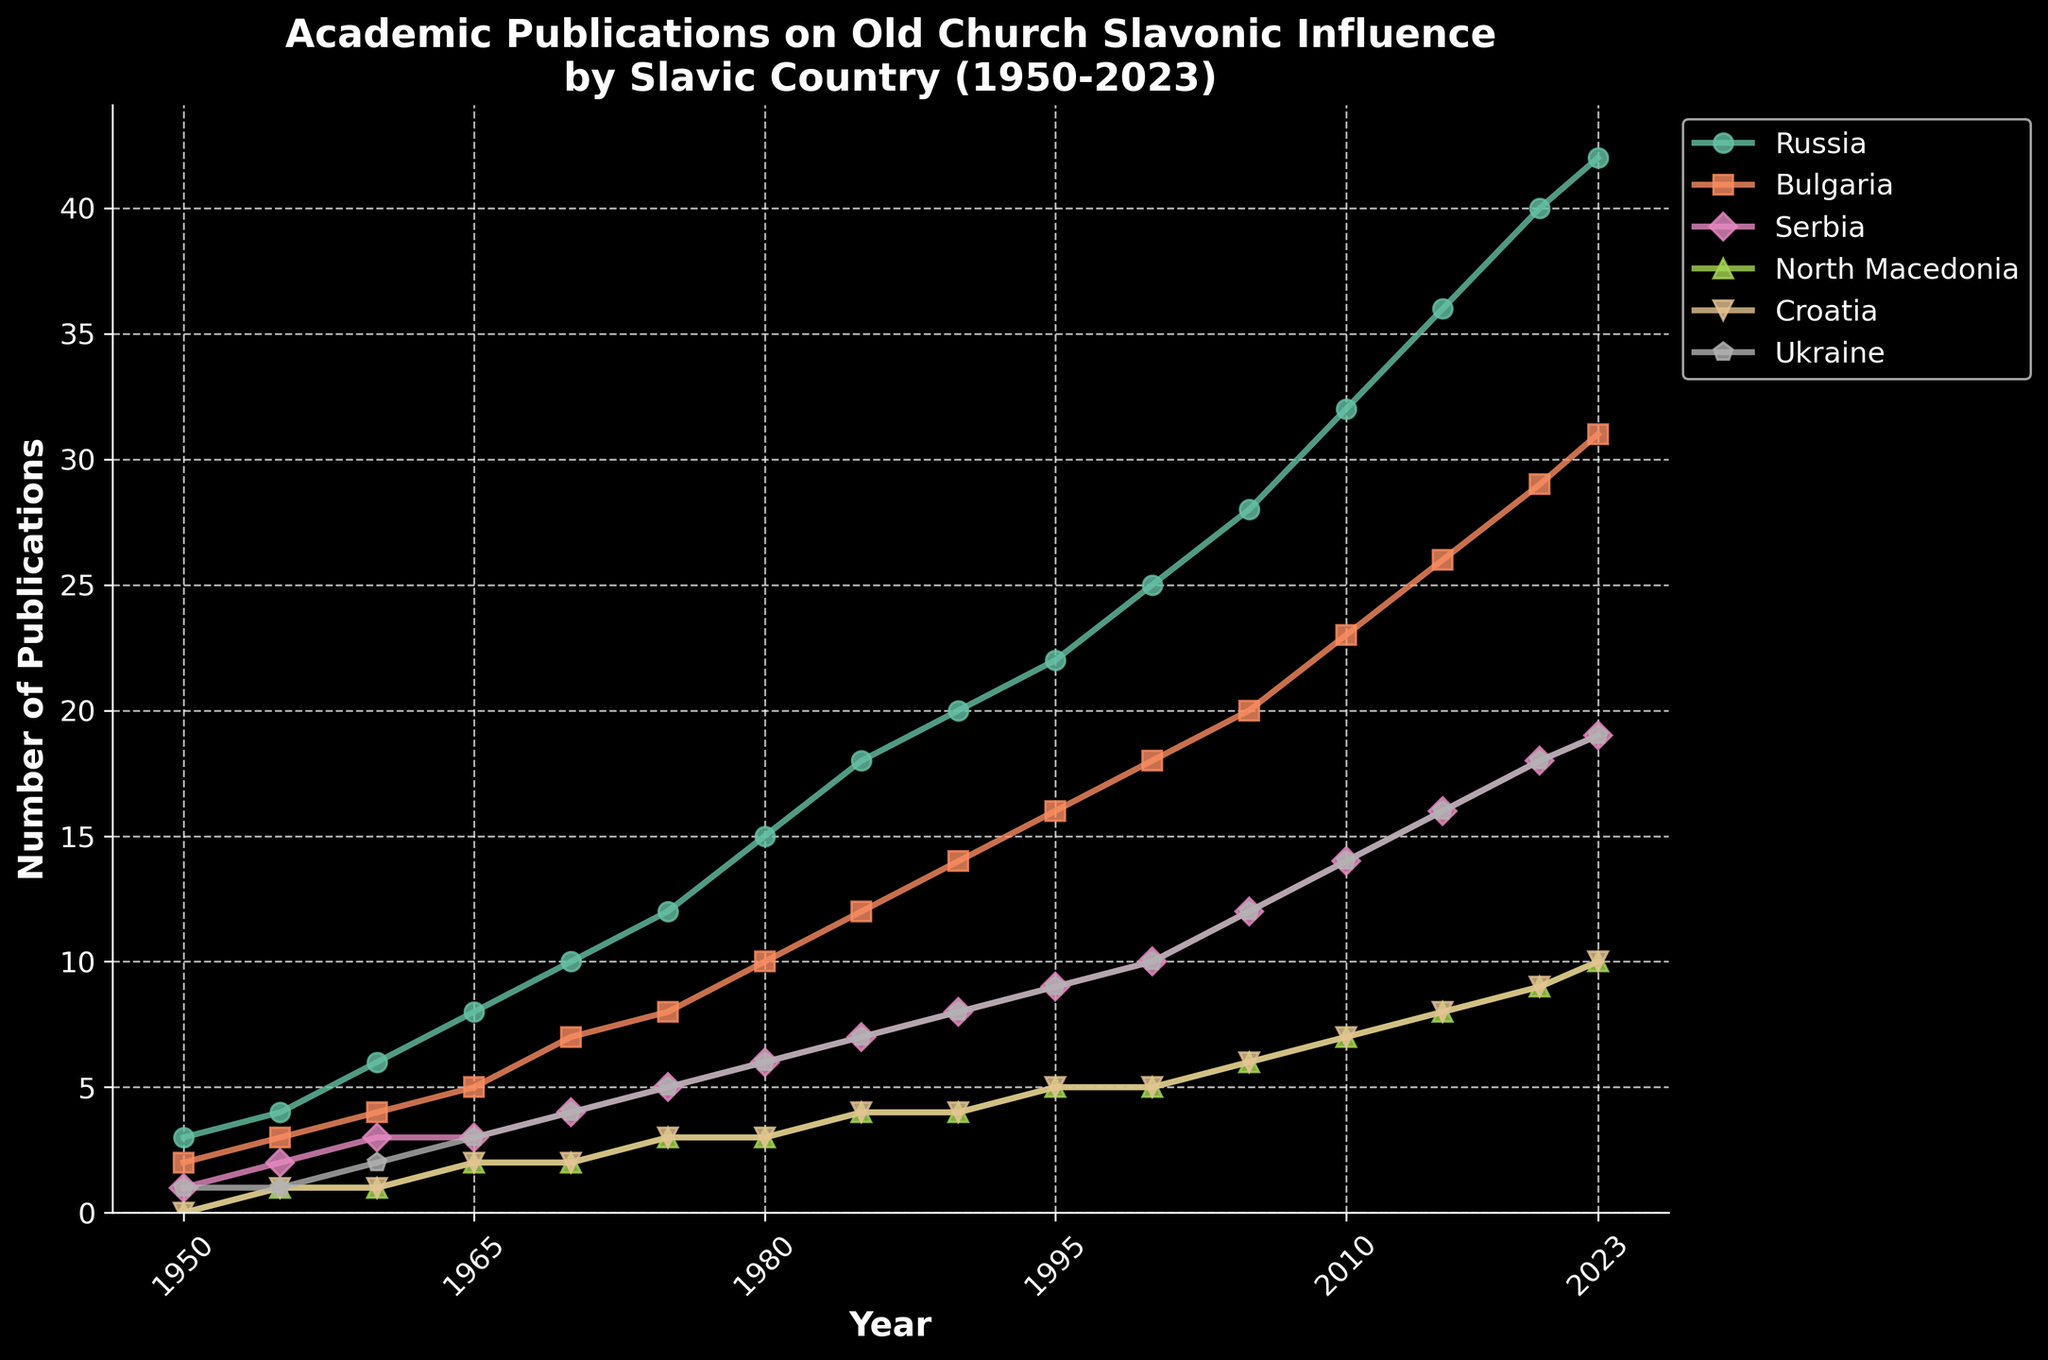Which country had the highest number of publications in the year 2023? To determine which country had the highest number of publications in 2023, look at the endpoints of the lines representing each country on the rightmost side of the figure. The line with the highest position on the y-axis indicates the country with the most publications. Russia's line is at the highest position.
Answer: Russia How many more publications did Russia have compared to North Macedonia in 1980? To find out how many more publications Russia had compared to North Macedonia in 1980, locate the corresponding points for both countries in the year 1980 on the x-axis. Note the y-values: Russia had 15 publications and North Macedonia had 3 publications. The difference is 15 - 3.
Answer: 12 Which country shows the most consistent increase in publications from 1950 to 2023? To determine the country with the most consistent increase, look at the slope and smoothness of each line. The line that rises steadily and smoothly without sharp increases or decreases indicates a consistent increase. Russia's line shows a smooth and steady increase over the years.
Answer: Russia What is the approximate total number of publications for Bulgaria and Serbia in the year 2005? For total publications from Bulgaria and Serbia in 2005, first find the y-values for both countries for that year: Bulgaria had 20 publications and Serbia had 12. Sum these values: 20 + 12.
Answer: 32 Between which two consecutive years did Croatia see the largest increase in publications? To identify the period with the largest increase for Croatia, analyze the line segments representing Croatia and look for the steepest rise. Between 2000 and 2005, the number of publications increased from 5 to 6, and between 2005 and 2010, from 6 to 7. The largest increase actually occurred between 2015 and 2020 when it goes from 8 to 9.
Answer: 2015 and 2020 How many publications did Ukraine have in total from 1980 to 2023? To find the total number of publications for Ukraine from 1980 to 2023, sum the y-values for the years 1980, 1985, 1990, 1995, 2000, 2005, 2010, 2015, 2020, and 2023: 6 + 7 + 8 + 9 + 10 + 12 + 14 + 16 + 18 + 19. This totals to 119.
Answer: 119 In which year did Bulgaria's number of publications surpass 20? To identify the year when Bulgaria's publications surpassed 20, find the point on Bulgaria's line that reaches above 20 on the y-axis. This occurs in the year after 2005, which is 2010 (as there is no data between these two points).
Answer: 2010 Which two countries had an equal number of publications in the year 1970? To find out which countries had an equal number of publications in 1970, locate the year 1970 on the x-axis and compare the y-values for each country. Bulgaria and Croatia both had 2 publications in 1970.
Answer: Bulgaria and Croatia What is the average number of publications for Serbia between 1965 and 1995? First, find the y-values for Serbia in 1965, 1970, 1975, 1980, 1985, 1990, and 1995: 3, 4, 5, 6, 7, 8, 9. Sum these values and divide by the number of data points: (3 + 4 + 5 + 6 + 7 + 8 + 9) / 7. This totals to 42/7.
Answer: 6 